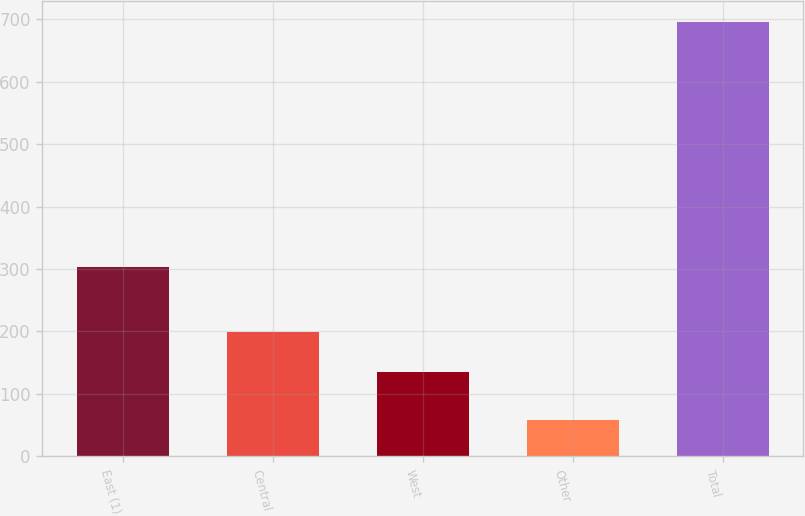Convert chart to OTSL. <chart><loc_0><loc_0><loc_500><loc_500><bar_chart><fcel>East (1)<fcel>Central<fcel>West<fcel>Other<fcel>Total<nl><fcel>303<fcel>199<fcel>135<fcel>58<fcel>695<nl></chart> 